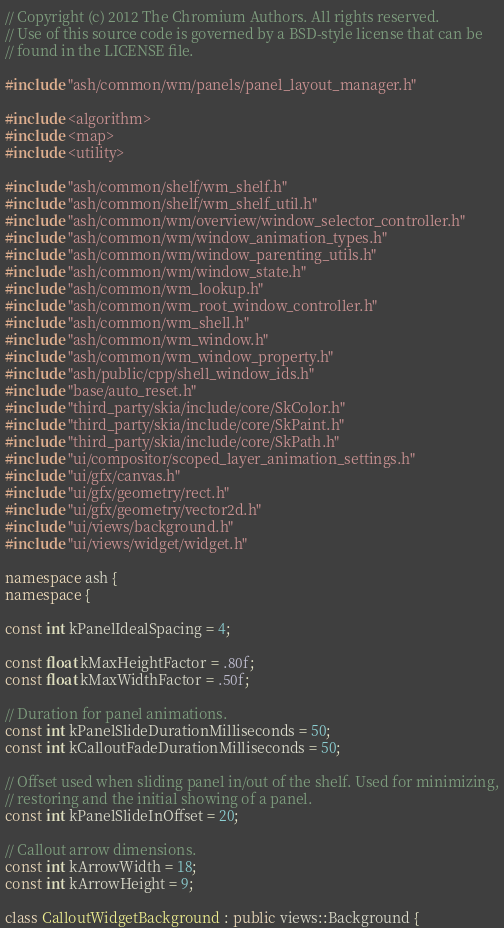<code> <loc_0><loc_0><loc_500><loc_500><_C++_>// Copyright (c) 2012 The Chromium Authors. All rights reserved.
// Use of this source code is governed by a BSD-style license that can be
// found in the LICENSE file.

#include "ash/common/wm/panels/panel_layout_manager.h"

#include <algorithm>
#include <map>
#include <utility>

#include "ash/common/shelf/wm_shelf.h"
#include "ash/common/shelf/wm_shelf_util.h"
#include "ash/common/wm/overview/window_selector_controller.h"
#include "ash/common/wm/window_animation_types.h"
#include "ash/common/wm/window_parenting_utils.h"
#include "ash/common/wm/window_state.h"
#include "ash/common/wm_lookup.h"
#include "ash/common/wm_root_window_controller.h"
#include "ash/common/wm_shell.h"
#include "ash/common/wm_window.h"
#include "ash/common/wm_window_property.h"
#include "ash/public/cpp/shell_window_ids.h"
#include "base/auto_reset.h"
#include "third_party/skia/include/core/SkColor.h"
#include "third_party/skia/include/core/SkPaint.h"
#include "third_party/skia/include/core/SkPath.h"
#include "ui/compositor/scoped_layer_animation_settings.h"
#include "ui/gfx/canvas.h"
#include "ui/gfx/geometry/rect.h"
#include "ui/gfx/geometry/vector2d.h"
#include "ui/views/background.h"
#include "ui/views/widget/widget.h"

namespace ash {
namespace {

const int kPanelIdealSpacing = 4;

const float kMaxHeightFactor = .80f;
const float kMaxWidthFactor = .50f;

// Duration for panel animations.
const int kPanelSlideDurationMilliseconds = 50;
const int kCalloutFadeDurationMilliseconds = 50;

// Offset used when sliding panel in/out of the shelf. Used for minimizing,
// restoring and the initial showing of a panel.
const int kPanelSlideInOffset = 20;

// Callout arrow dimensions.
const int kArrowWidth = 18;
const int kArrowHeight = 9;

class CalloutWidgetBackground : public views::Background {</code> 